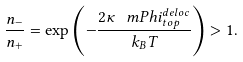<formula> <loc_0><loc_0><loc_500><loc_500>\frac { n _ { - } } { n _ { + } } = \exp \left ( - \frac { 2 \kappa \, \ m P h i _ { t o p } ^ { d e l o c } } { k _ { B } T } \right ) > 1 .</formula> 